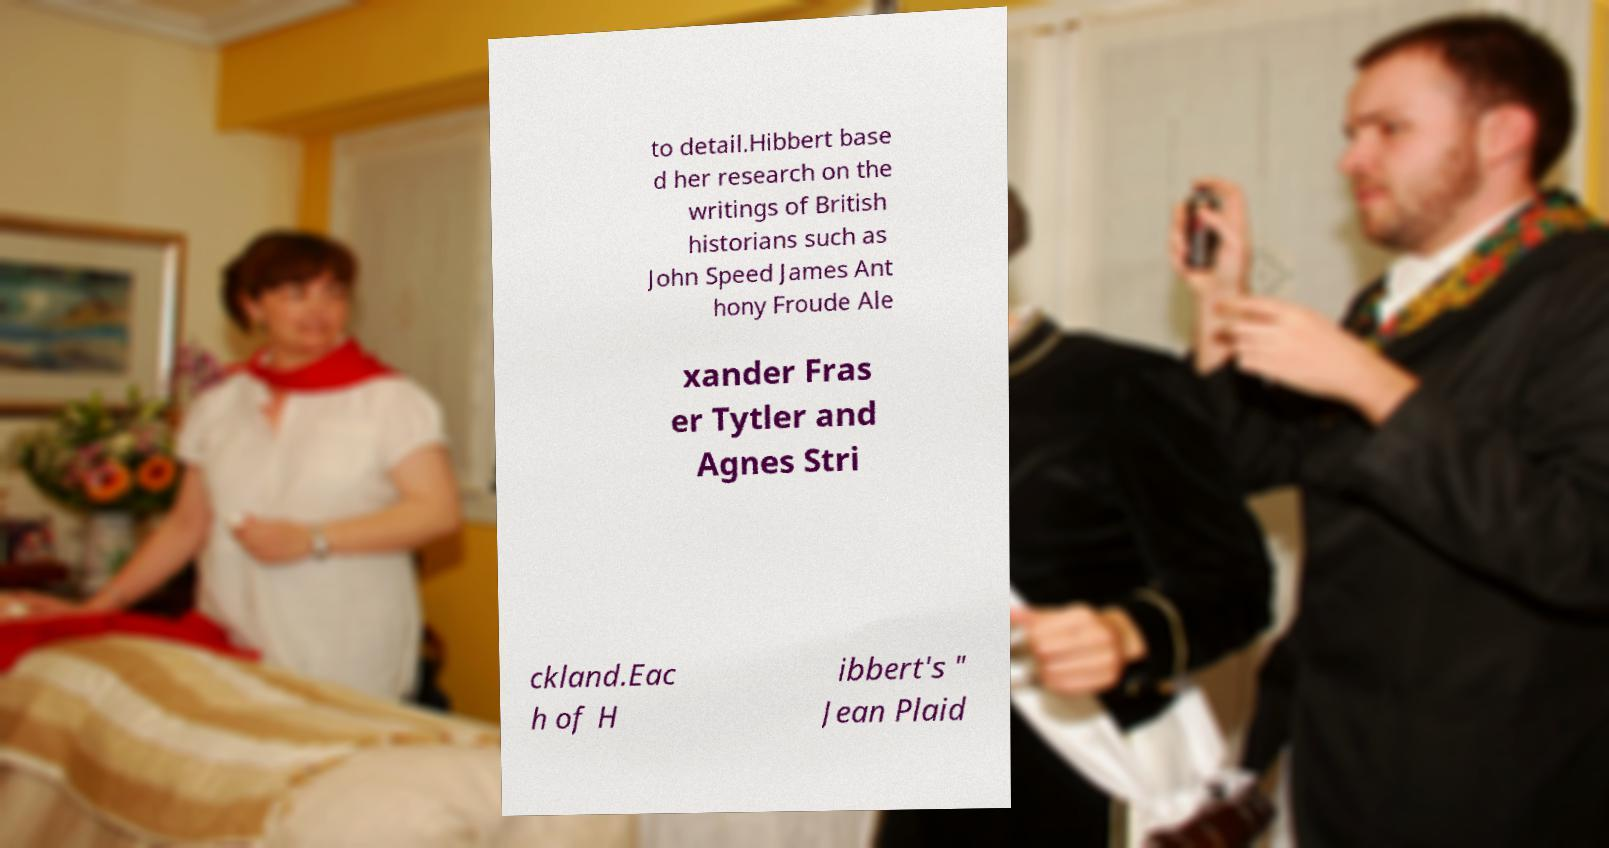There's text embedded in this image that I need extracted. Can you transcribe it verbatim? to detail.Hibbert base d her research on the writings of British historians such as John Speed James Ant hony Froude Ale xander Fras er Tytler and Agnes Stri ckland.Eac h of H ibbert's " Jean Plaid 